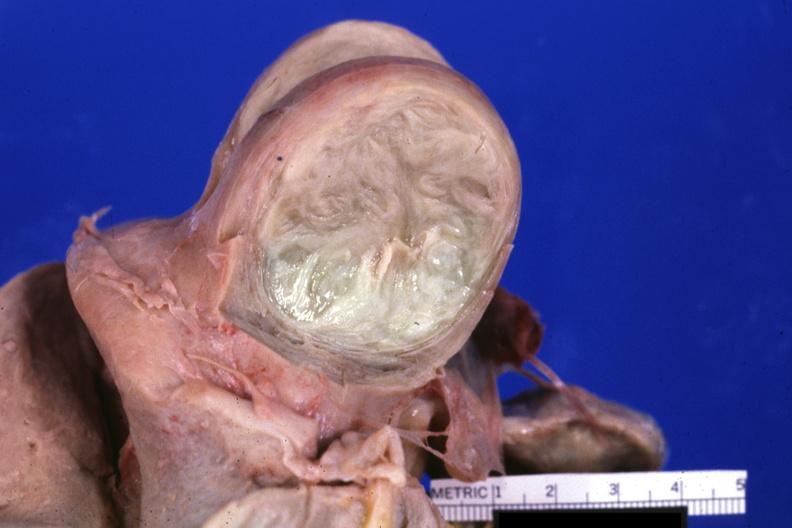s cm cut surface of typical myoma?
Answer the question using a single word or phrase. No 